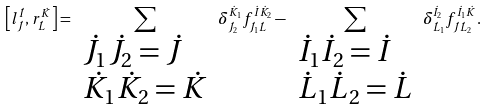Convert formula to latex. <formula><loc_0><loc_0><loc_500><loc_500>\left [ l _ { \dot { J } } ^ { \dot { I } } , r _ { \dot { L } } ^ { \dot { K } } \right ] = \sum _ { \begin{array} { l } { { \dot { J } _ { 1 } \dot { J } _ { 2 } = \dot { J } } } \\ { { \dot { K } _ { 1 } \dot { K } _ { 2 } = \dot { K } } } \end{array} } \delta _ { \dot { J } _ { 2 } } ^ { \dot { K } _ { 1 } } f _ { \dot { J } _ { 1 } \dot { L } } ^ { \dot { I } \dot { K } _ { 2 } } - \sum _ { \begin{array} { l } { { \dot { I } _ { 1 } \dot { I } _ { 2 } = \dot { I } } } \\ { { \dot { L } _ { 1 } \dot { L } _ { 2 } = \dot { L } } } \end{array} } \delta _ { \dot { L } _ { 1 } } ^ { \dot { I } _ { 2 } } f _ { \dot { J } \dot { L } _ { 2 } } ^ { \dot { I } _ { 1 } \dot { K } } .</formula> 